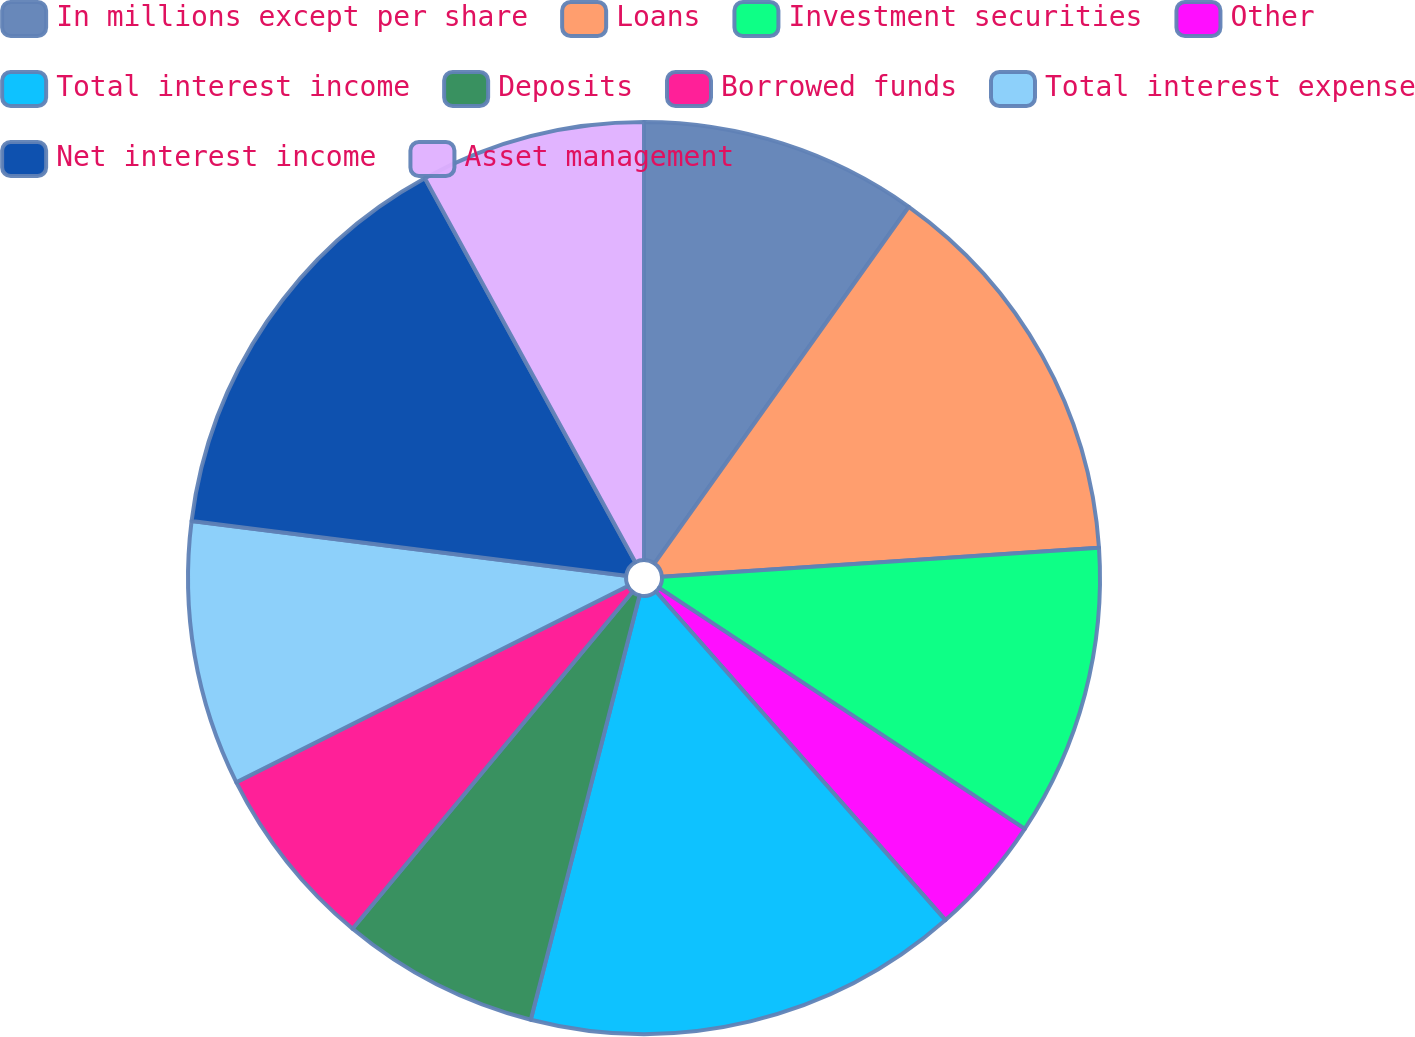Convert chart to OTSL. <chart><loc_0><loc_0><loc_500><loc_500><pie_chart><fcel>In millions except per share<fcel>Loans<fcel>Investment securities<fcel>Other<fcel>Total interest income<fcel>Deposits<fcel>Borrowed funds<fcel>Total interest expense<fcel>Net interest income<fcel>Asset management<nl><fcel>9.86%<fcel>14.08%<fcel>10.33%<fcel>4.23%<fcel>15.49%<fcel>7.04%<fcel>6.57%<fcel>9.39%<fcel>15.02%<fcel>7.98%<nl></chart> 